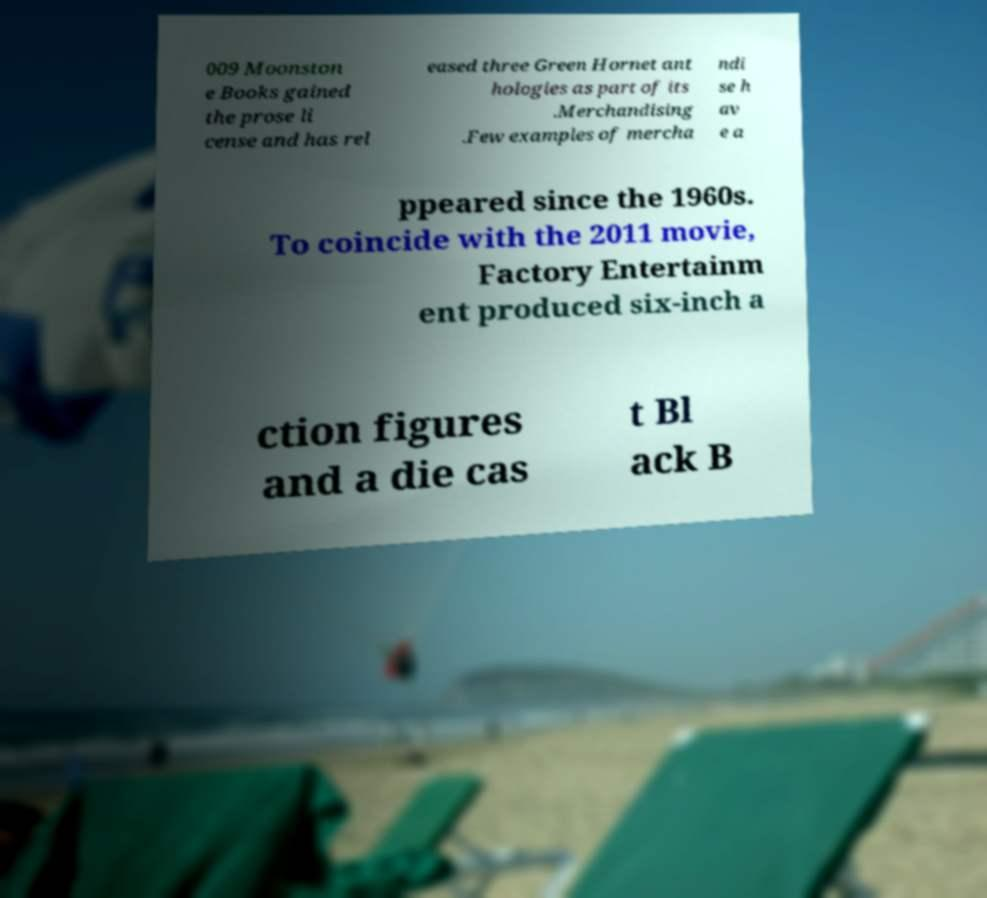Could you assist in decoding the text presented in this image and type it out clearly? 009 Moonston e Books gained the prose li cense and has rel eased three Green Hornet ant hologies as part of its .Merchandising .Few examples of mercha ndi se h av e a ppeared since the 1960s. To coincide with the 2011 movie, Factory Entertainm ent produced six-inch a ction figures and a die cas t Bl ack B 